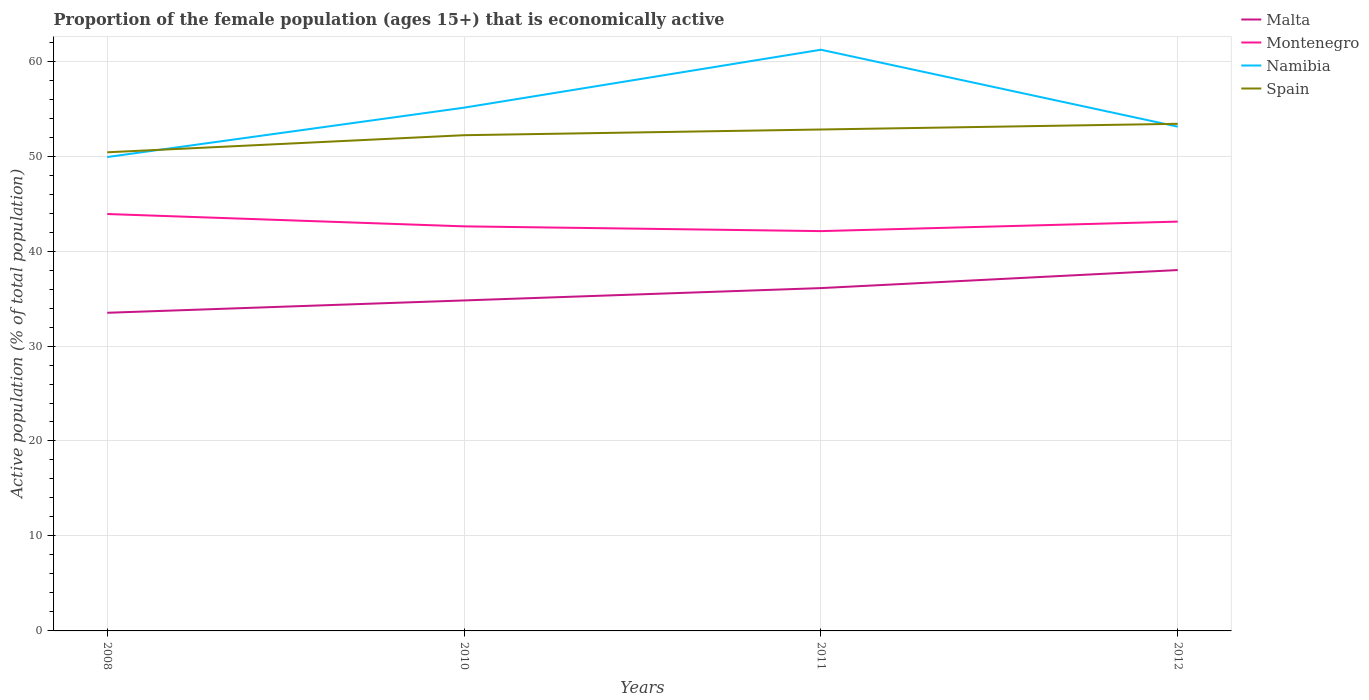Does the line corresponding to Malta intersect with the line corresponding to Spain?
Offer a very short reply. No. Is the number of lines equal to the number of legend labels?
Your answer should be compact. Yes. Across all years, what is the maximum proportion of the female population that is economically active in Malta?
Offer a terse response. 33.5. What is the total proportion of the female population that is economically active in Malta in the graph?
Make the answer very short. -2.6. What is the difference between the highest and the second highest proportion of the female population that is economically active in Montenegro?
Keep it short and to the point. 1.8. Is the proportion of the female population that is economically active in Malta strictly greater than the proportion of the female population that is economically active in Spain over the years?
Ensure brevity in your answer.  Yes. What is the difference between two consecutive major ticks on the Y-axis?
Give a very brief answer. 10. Are the values on the major ticks of Y-axis written in scientific E-notation?
Your response must be concise. No. How many legend labels are there?
Offer a terse response. 4. What is the title of the graph?
Provide a succinct answer. Proportion of the female population (ages 15+) that is economically active. Does "El Salvador" appear as one of the legend labels in the graph?
Provide a succinct answer. No. What is the label or title of the Y-axis?
Offer a very short reply. Active population (% of total population). What is the Active population (% of total population) of Malta in 2008?
Make the answer very short. 33.5. What is the Active population (% of total population) of Montenegro in 2008?
Your response must be concise. 43.9. What is the Active population (% of total population) of Namibia in 2008?
Your response must be concise. 49.9. What is the Active population (% of total population) of Spain in 2008?
Your answer should be compact. 50.4. What is the Active population (% of total population) of Malta in 2010?
Provide a succinct answer. 34.8. What is the Active population (% of total population) in Montenegro in 2010?
Your response must be concise. 42.6. What is the Active population (% of total population) in Namibia in 2010?
Offer a terse response. 55.1. What is the Active population (% of total population) of Spain in 2010?
Provide a succinct answer. 52.2. What is the Active population (% of total population) in Malta in 2011?
Make the answer very short. 36.1. What is the Active population (% of total population) of Montenegro in 2011?
Offer a terse response. 42.1. What is the Active population (% of total population) in Namibia in 2011?
Your response must be concise. 61.2. What is the Active population (% of total population) in Spain in 2011?
Provide a short and direct response. 52.8. What is the Active population (% of total population) of Malta in 2012?
Your answer should be very brief. 38. What is the Active population (% of total population) in Montenegro in 2012?
Offer a very short reply. 43.1. What is the Active population (% of total population) of Namibia in 2012?
Offer a very short reply. 53.1. What is the Active population (% of total population) in Spain in 2012?
Your response must be concise. 53.4. Across all years, what is the maximum Active population (% of total population) of Malta?
Provide a succinct answer. 38. Across all years, what is the maximum Active population (% of total population) in Montenegro?
Ensure brevity in your answer.  43.9. Across all years, what is the maximum Active population (% of total population) of Namibia?
Offer a terse response. 61.2. Across all years, what is the maximum Active population (% of total population) of Spain?
Provide a succinct answer. 53.4. Across all years, what is the minimum Active population (% of total population) of Malta?
Your response must be concise. 33.5. Across all years, what is the minimum Active population (% of total population) in Montenegro?
Make the answer very short. 42.1. Across all years, what is the minimum Active population (% of total population) in Namibia?
Offer a terse response. 49.9. Across all years, what is the minimum Active population (% of total population) in Spain?
Make the answer very short. 50.4. What is the total Active population (% of total population) of Malta in the graph?
Your answer should be compact. 142.4. What is the total Active population (% of total population) in Montenegro in the graph?
Offer a terse response. 171.7. What is the total Active population (% of total population) in Namibia in the graph?
Offer a very short reply. 219.3. What is the total Active population (% of total population) of Spain in the graph?
Provide a short and direct response. 208.8. What is the difference between the Active population (% of total population) in Montenegro in 2008 and that in 2010?
Provide a succinct answer. 1.3. What is the difference between the Active population (% of total population) of Namibia in 2008 and that in 2010?
Your answer should be compact. -5.2. What is the difference between the Active population (% of total population) of Malta in 2008 and that in 2011?
Your answer should be compact. -2.6. What is the difference between the Active population (% of total population) of Montenegro in 2008 and that in 2011?
Keep it short and to the point. 1.8. What is the difference between the Active population (% of total population) of Namibia in 2008 and that in 2011?
Ensure brevity in your answer.  -11.3. What is the difference between the Active population (% of total population) of Namibia in 2008 and that in 2012?
Offer a terse response. -3.2. What is the difference between the Active population (% of total population) of Montenegro in 2010 and that in 2011?
Offer a very short reply. 0.5. What is the difference between the Active population (% of total population) in Namibia in 2010 and that in 2011?
Offer a very short reply. -6.1. What is the difference between the Active population (% of total population) of Malta in 2010 and that in 2012?
Make the answer very short. -3.2. What is the difference between the Active population (% of total population) in Montenegro in 2011 and that in 2012?
Offer a terse response. -1. What is the difference between the Active population (% of total population) in Namibia in 2011 and that in 2012?
Ensure brevity in your answer.  8.1. What is the difference between the Active population (% of total population) of Malta in 2008 and the Active population (% of total population) of Montenegro in 2010?
Provide a short and direct response. -9.1. What is the difference between the Active population (% of total population) of Malta in 2008 and the Active population (% of total population) of Namibia in 2010?
Keep it short and to the point. -21.6. What is the difference between the Active population (% of total population) in Malta in 2008 and the Active population (% of total population) in Spain in 2010?
Offer a terse response. -18.7. What is the difference between the Active population (% of total population) in Montenegro in 2008 and the Active population (% of total population) in Namibia in 2010?
Offer a terse response. -11.2. What is the difference between the Active population (% of total population) of Namibia in 2008 and the Active population (% of total population) of Spain in 2010?
Give a very brief answer. -2.3. What is the difference between the Active population (% of total population) in Malta in 2008 and the Active population (% of total population) in Montenegro in 2011?
Give a very brief answer. -8.6. What is the difference between the Active population (% of total population) in Malta in 2008 and the Active population (% of total population) in Namibia in 2011?
Offer a very short reply. -27.7. What is the difference between the Active population (% of total population) in Malta in 2008 and the Active population (% of total population) in Spain in 2011?
Your answer should be compact. -19.3. What is the difference between the Active population (% of total population) of Montenegro in 2008 and the Active population (% of total population) of Namibia in 2011?
Offer a terse response. -17.3. What is the difference between the Active population (% of total population) of Montenegro in 2008 and the Active population (% of total population) of Spain in 2011?
Keep it short and to the point. -8.9. What is the difference between the Active population (% of total population) of Malta in 2008 and the Active population (% of total population) of Namibia in 2012?
Ensure brevity in your answer.  -19.6. What is the difference between the Active population (% of total population) in Malta in 2008 and the Active population (% of total population) in Spain in 2012?
Offer a very short reply. -19.9. What is the difference between the Active population (% of total population) in Namibia in 2008 and the Active population (% of total population) in Spain in 2012?
Offer a terse response. -3.5. What is the difference between the Active population (% of total population) of Malta in 2010 and the Active population (% of total population) of Namibia in 2011?
Keep it short and to the point. -26.4. What is the difference between the Active population (% of total population) of Malta in 2010 and the Active population (% of total population) of Spain in 2011?
Your answer should be very brief. -18. What is the difference between the Active population (% of total population) of Montenegro in 2010 and the Active population (% of total population) of Namibia in 2011?
Offer a terse response. -18.6. What is the difference between the Active population (% of total population) in Malta in 2010 and the Active population (% of total population) in Montenegro in 2012?
Your answer should be very brief. -8.3. What is the difference between the Active population (% of total population) of Malta in 2010 and the Active population (% of total population) of Namibia in 2012?
Your response must be concise. -18.3. What is the difference between the Active population (% of total population) of Malta in 2010 and the Active population (% of total population) of Spain in 2012?
Offer a terse response. -18.6. What is the difference between the Active population (% of total population) of Montenegro in 2010 and the Active population (% of total population) of Namibia in 2012?
Your response must be concise. -10.5. What is the difference between the Active population (% of total population) of Montenegro in 2010 and the Active population (% of total population) of Spain in 2012?
Your answer should be compact. -10.8. What is the difference between the Active population (% of total population) of Malta in 2011 and the Active population (% of total population) of Namibia in 2012?
Your answer should be compact. -17. What is the difference between the Active population (% of total population) in Malta in 2011 and the Active population (% of total population) in Spain in 2012?
Your answer should be compact. -17.3. What is the difference between the Active population (% of total population) in Namibia in 2011 and the Active population (% of total population) in Spain in 2012?
Make the answer very short. 7.8. What is the average Active population (% of total population) in Malta per year?
Your answer should be compact. 35.6. What is the average Active population (% of total population) of Montenegro per year?
Offer a terse response. 42.92. What is the average Active population (% of total population) in Namibia per year?
Keep it short and to the point. 54.83. What is the average Active population (% of total population) of Spain per year?
Make the answer very short. 52.2. In the year 2008, what is the difference between the Active population (% of total population) in Malta and Active population (% of total population) in Montenegro?
Offer a terse response. -10.4. In the year 2008, what is the difference between the Active population (% of total population) in Malta and Active population (% of total population) in Namibia?
Your response must be concise. -16.4. In the year 2008, what is the difference between the Active population (% of total population) of Malta and Active population (% of total population) of Spain?
Provide a succinct answer. -16.9. In the year 2008, what is the difference between the Active population (% of total population) in Montenegro and Active population (% of total population) in Spain?
Make the answer very short. -6.5. In the year 2008, what is the difference between the Active population (% of total population) of Namibia and Active population (% of total population) of Spain?
Give a very brief answer. -0.5. In the year 2010, what is the difference between the Active population (% of total population) in Malta and Active population (% of total population) in Namibia?
Offer a very short reply. -20.3. In the year 2010, what is the difference between the Active population (% of total population) in Malta and Active population (% of total population) in Spain?
Ensure brevity in your answer.  -17.4. In the year 2010, what is the difference between the Active population (% of total population) of Montenegro and Active population (% of total population) of Spain?
Offer a very short reply. -9.6. In the year 2011, what is the difference between the Active population (% of total population) in Malta and Active population (% of total population) in Montenegro?
Offer a very short reply. -6. In the year 2011, what is the difference between the Active population (% of total population) of Malta and Active population (% of total population) of Namibia?
Your answer should be compact. -25.1. In the year 2011, what is the difference between the Active population (% of total population) in Malta and Active population (% of total population) in Spain?
Ensure brevity in your answer.  -16.7. In the year 2011, what is the difference between the Active population (% of total population) of Montenegro and Active population (% of total population) of Namibia?
Keep it short and to the point. -19.1. In the year 2012, what is the difference between the Active population (% of total population) of Malta and Active population (% of total population) of Montenegro?
Provide a succinct answer. -5.1. In the year 2012, what is the difference between the Active population (% of total population) of Malta and Active population (% of total population) of Namibia?
Offer a very short reply. -15.1. In the year 2012, what is the difference between the Active population (% of total population) of Malta and Active population (% of total population) of Spain?
Your answer should be very brief. -15.4. In the year 2012, what is the difference between the Active population (% of total population) of Montenegro and Active population (% of total population) of Namibia?
Make the answer very short. -10. In the year 2012, what is the difference between the Active population (% of total population) in Montenegro and Active population (% of total population) in Spain?
Keep it short and to the point. -10.3. What is the ratio of the Active population (% of total population) in Malta in 2008 to that in 2010?
Keep it short and to the point. 0.96. What is the ratio of the Active population (% of total population) of Montenegro in 2008 to that in 2010?
Offer a terse response. 1.03. What is the ratio of the Active population (% of total population) of Namibia in 2008 to that in 2010?
Ensure brevity in your answer.  0.91. What is the ratio of the Active population (% of total population) in Spain in 2008 to that in 2010?
Ensure brevity in your answer.  0.97. What is the ratio of the Active population (% of total population) in Malta in 2008 to that in 2011?
Your answer should be very brief. 0.93. What is the ratio of the Active population (% of total population) of Montenegro in 2008 to that in 2011?
Your answer should be very brief. 1.04. What is the ratio of the Active population (% of total population) in Namibia in 2008 to that in 2011?
Your response must be concise. 0.82. What is the ratio of the Active population (% of total population) in Spain in 2008 to that in 2011?
Make the answer very short. 0.95. What is the ratio of the Active population (% of total population) of Malta in 2008 to that in 2012?
Offer a very short reply. 0.88. What is the ratio of the Active population (% of total population) in Montenegro in 2008 to that in 2012?
Your response must be concise. 1.02. What is the ratio of the Active population (% of total population) in Namibia in 2008 to that in 2012?
Ensure brevity in your answer.  0.94. What is the ratio of the Active population (% of total population) of Spain in 2008 to that in 2012?
Offer a terse response. 0.94. What is the ratio of the Active population (% of total population) in Malta in 2010 to that in 2011?
Offer a terse response. 0.96. What is the ratio of the Active population (% of total population) of Montenegro in 2010 to that in 2011?
Offer a terse response. 1.01. What is the ratio of the Active population (% of total population) of Namibia in 2010 to that in 2011?
Provide a short and direct response. 0.9. What is the ratio of the Active population (% of total population) in Spain in 2010 to that in 2011?
Keep it short and to the point. 0.99. What is the ratio of the Active population (% of total population) in Malta in 2010 to that in 2012?
Make the answer very short. 0.92. What is the ratio of the Active population (% of total population) in Montenegro in 2010 to that in 2012?
Offer a very short reply. 0.99. What is the ratio of the Active population (% of total population) in Namibia in 2010 to that in 2012?
Offer a terse response. 1.04. What is the ratio of the Active population (% of total population) in Spain in 2010 to that in 2012?
Keep it short and to the point. 0.98. What is the ratio of the Active population (% of total population) of Malta in 2011 to that in 2012?
Offer a terse response. 0.95. What is the ratio of the Active population (% of total population) of Montenegro in 2011 to that in 2012?
Offer a terse response. 0.98. What is the ratio of the Active population (% of total population) in Namibia in 2011 to that in 2012?
Offer a very short reply. 1.15. What is the ratio of the Active population (% of total population) in Spain in 2011 to that in 2012?
Ensure brevity in your answer.  0.99. What is the difference between the highest and the second highest Active population (% of total population) in Montenegro?
Provide a succinct answer. 0.8. What is the difference between the highest and the second highest Active population (% of total population) of Namibia?
Ensure brevity in your answer.  6.1. What is the difference between the highest and the second highest Active population (% of total population) of Spain?
Your answer should be very brief. 0.6. What is the difference between the highest and the lowest Active population (% of total population) in Montenegro?
Provide a short and direct response. 1.8. 